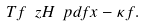<formula> <loc_0><loc_0><loc_500><loc_500>T f \ z H \ p d f x - \kappa f .</formula> 